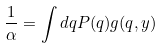<formula> <loc_0><loc_0><loc_500><loc_500>\frac { 1 } { \alpha } = \int d q P ( q ) g ( q , y )</formula> 